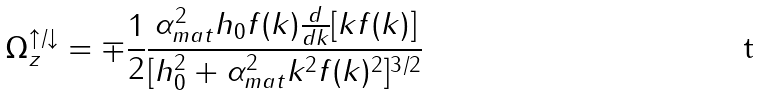<formula> <loc_0><loc_0><loc_500><loc_500>\Omega _ { z } ^ { \uparrow / \downarrow } = \mp \frac { 1 } { 2 } \frac { \alpha _ { m a t } ^ { 2 } h _ { 0 } f ( k ) \frac { d } { d k } [ k f ( k ) ] } { [ h _ { 0 } ^ { 2 } + \alpha _ { m a t } ^ { 2 } k ^ { 2 } f ( k ) ^ { 2 } ] ^ { 3 / 2 } }</formula> 